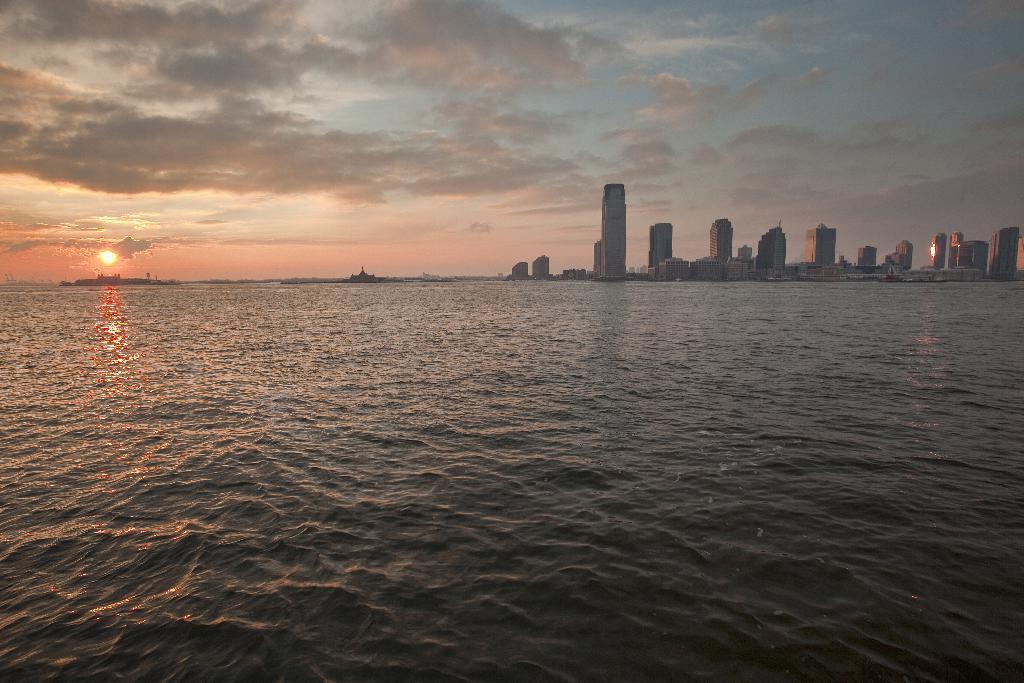In one or two sentences, can you explain what this image depicts? In this image I can see in the middle it looks like a river, on the right side there are buildings. On the left side there is the sun in the sky. 